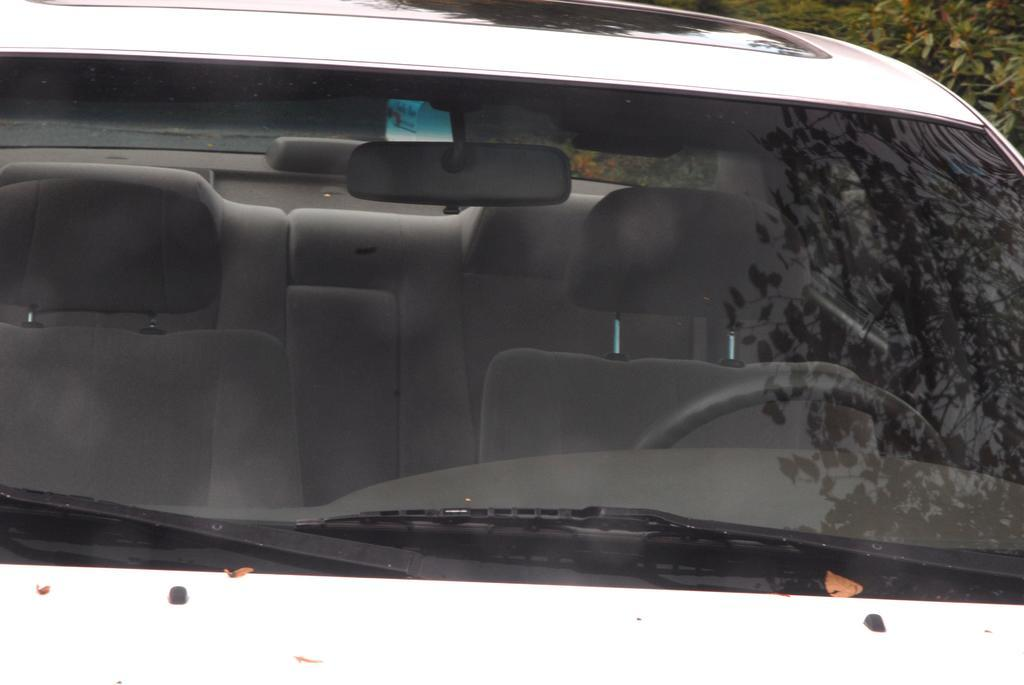What color is the car in the image? The car in the image is white. What features are present inside the car? The car has seats and a steering wheel. What is visible in the car's front mirror? There is a reflection of trees and the sky in the car's front mirror. Can you tell me what time it is on the watch in the image? There is no watch present in the image. What type of road is visible in the image? There is no road visible in the image; it only shows a car with a front mirror reflecting trees and the sky. 